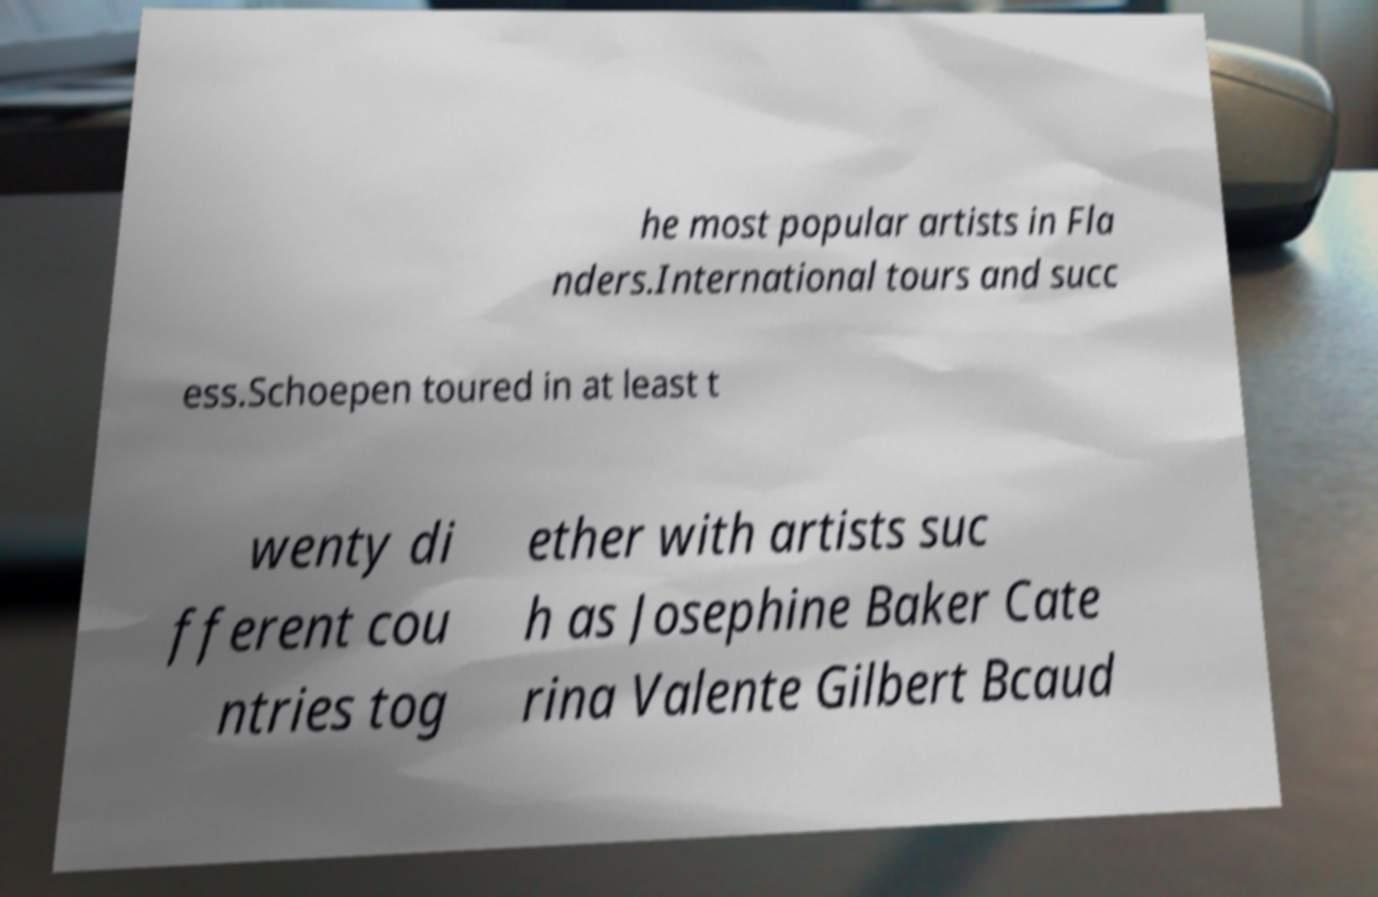Please identify and transcribe the text found in this image. he most popular artists in Fla nders.International tours and succ ess.Schoepen toured in at least t wenty di fferent cou ntries tog ether with artists suc h as Josephine Baker Cate rina Valente Gilbert Bcaud 